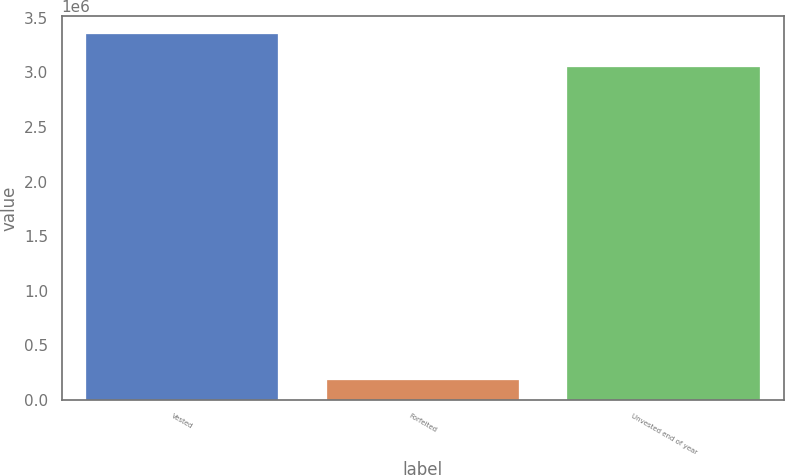Convert chart. <chart><loc_0><loc_0><loc_500><loc_500><bar_chart><fcel>Vested<fcel>Forfeited<fcel>Unvested end of year<nl><fcel>3.34969e+06<fcel>185705<fcel>3.04696e+06<nl></chart> 